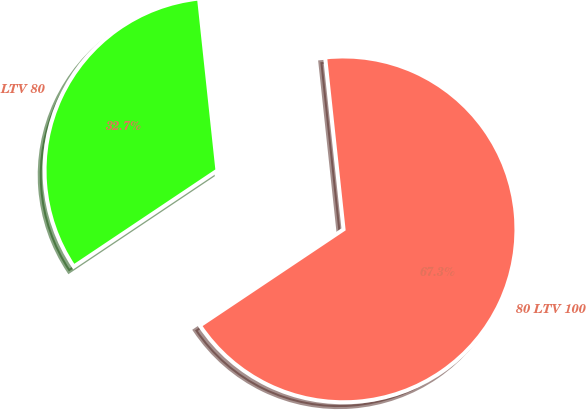Convert chart. <chart><loc_0><loc_0><loc_500><loc_500><pie_chart><fcel>LTV 80<fcel>80 LTV 100<nl><fcel>32.69%<fcel>67.31%<nl></chart> 